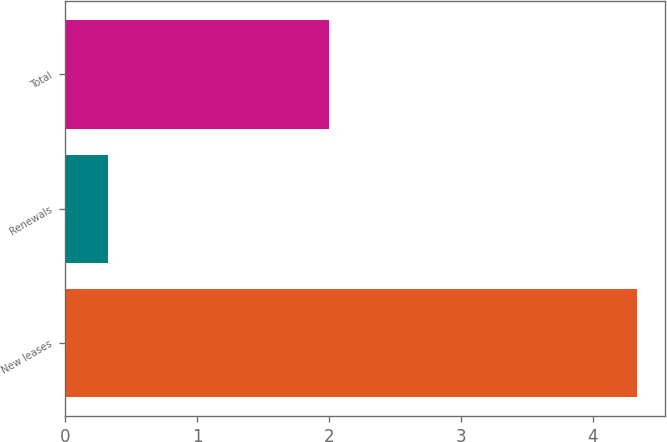<chart> <loc_0><loc_0><loc_500><loc_500><bar_chart><fcel>New leases<fcel>Renewals<fcel>Total<nl><fcel>4.33<fcel>0.32<fcel>2<nl></chart> 